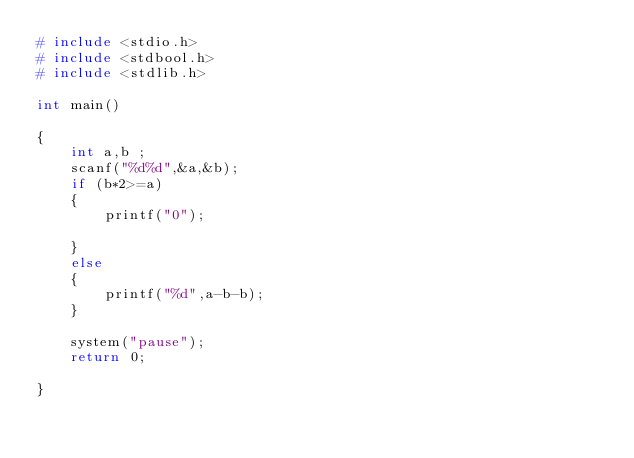<code> <loc_0><loc_0><loc_500><loc_500><_C_># include <stdio.h>
# include <stdbool.h>
# include <stdlib.h>

int main()

{
    int a,b ;
    scanf("%d%d",&a,&b);
    if (b*2>=a)
    {
        printf("0");

    }
    else
    {
        printf("%d",a-b-b);
    }
    
    system("pause");
    return 0;

}</code> 